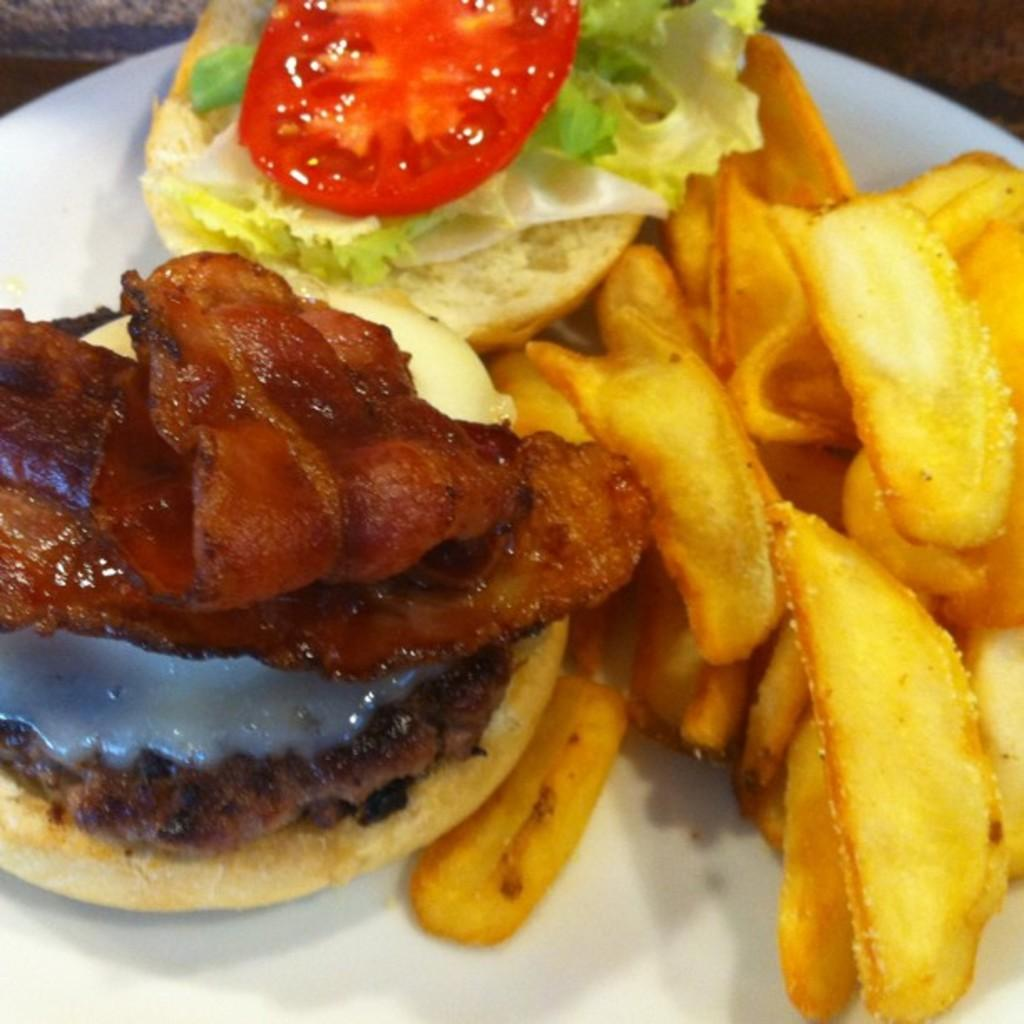What is present on the plate in the image? There is food on the plate in the image. Can you describe the plate in the image? The plate is visible in the image, but no specific details about its appearance are provided. What type of pickle is being used to open the door in the image? There is no pickle or door present in the image; it only features a plate with food on it. 